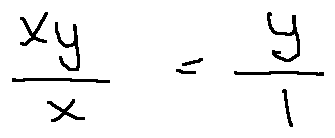Convert formula to latex. <formula><loc_0><loc_0><loc_500><loc_500>\frac { x y } { x } = \frac { y } { 1 }</formula> 